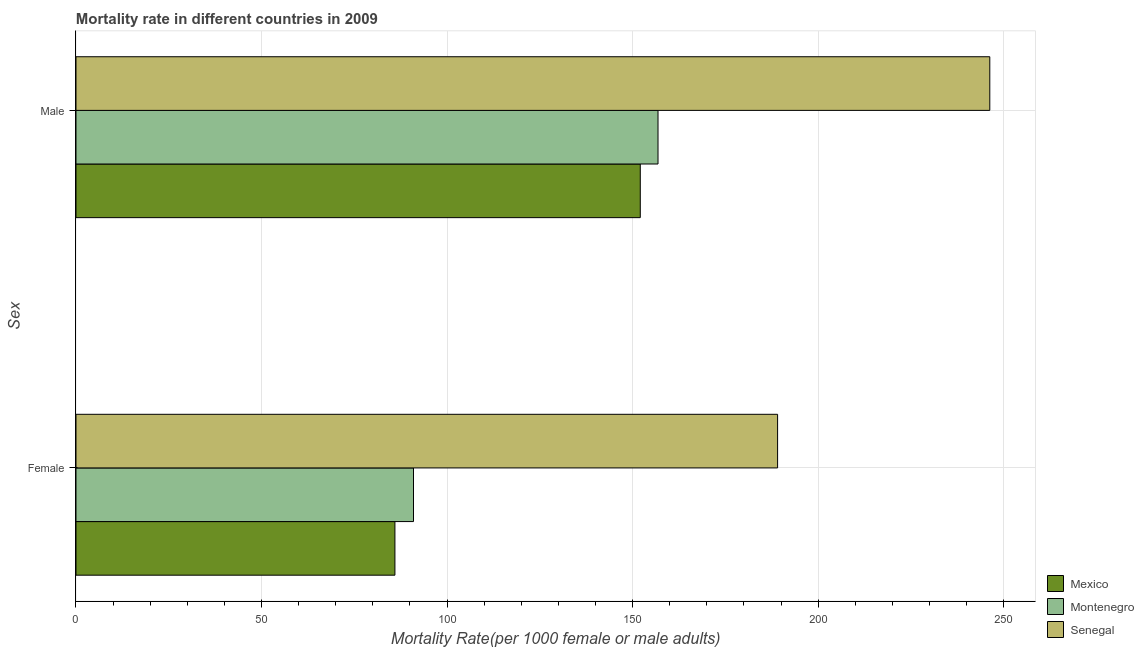How many groups of bars are there?
Offer a very short reply. 2. How many bars are there on the 2nd tick from the top?
Give a very brief answer. 3. What is the female mortality rate in Senegal?
Ensure brevity in your answer.  189.07. Across all countries, what is the maximum male mortality rate?
Your answer should be compact. 246.25. Across all countries, what is the minimum female mortality rate?
Ensure brevity in your answer.  85.95. In which country was the female mortality rate maximum?
Offer a terse response. Senegal. In which country was the female mortality rate minimum?
Provide a succinct answer. Mexico. What is the total female mortality rate in the graph?
Provide a short and direct response. 365.96. What is the difference between the male mortality rate in Senegal and that in Montenegro?
Provide a succinct answer. 89.41. What is the difference between the female mortality rate in Mexico and the male mortality rate in Montenegro?
Keep it short and to the point. -70.9. What is the average male mortality rate per country?
Your answer should be very brief. 185.05. What is the difference between the male mortality rate and female mortality rate in Mexico?
Provide a short and direct response. 66.12. In how many countries, is the female mortality rate greater than 210 ?
Offer a very short reply. 0. What is the ratio of the male mortality rate in Mexico to that in Senegal?
Ensure brevity in your answer.  0.62. Is the female mortality rate in Mexico less than that in Senegal?
Provide a succinct answer. Yes. In how many countries, is the female mortality rate greater than the average female mortality rate taken over all countries?
Offer a very short reply. 1. What does the 1st bar from the top in Male represents?
Your response must be concise. Senegal. What does the 2nd bar from the bottom in Male represents?
Give a very brief answer. Montenegro. How many bars are there?
Your response must be concise. 6. Are the values on the major ticks of X-axis written in scientific E-notation?
Your answer should be compact. No. Does the graph contain grids?
Offer a very short reply. Yes. Where does the legend appear in the graph?
Offer a terse response. Bottom right. How are the legend labels stacked?
Give a very brief answer. Vertical. What is the title of the graph?
Provide a short and direct response. Mortality rate in different countries in 2009. What is the label or title of the X-axis?
Keep it short and to the point. Mortality Rate(per 1000 female or male adults). What is the label or title of the Y-axis?
Give a very brief answer. Sex. What is the Mortality Rate(per 1000 female or male adults) in Mexico in Female?
Keep it short and to the point. 85.95. What is the Mortality Rate(per 1000 female or male adults) in Montenegro in Female?
Give a very brief answer. 90.95. What is the Mortality Rate(per 1000 female or male adults) of Senegal in Female?
Offer a terse response. 189.07. What is the Mortality Rate(per 1000 female or male adults) in Mexico in Male?
Provide a short and direct response. 152.06. What is the Mortality Rate(per 1000 female or male adults) of Montenegro in Male?
Make the answer very short. 156.84. What is the Mortality Rate(per 1000 female or male adults) of Senegal in Male?
Ensure brevity in your answer.  246.25. Across all Sex, what is the maximum Mortality Rate(per 1000 female or male adults) of Mexico?
Give a very brief answer. 152.06. Across all Sex, what is the maximum Mortality Rate(per 1000 female or male adults) of Montenegro?
Your answer should be compact. 156.84. Across all Sex, what is the maximum Mortality Rate(per 1000 female or male adults) of Senegal?
Offer a terse response. 246.25. Across all Sex, what is the minimum Mortality Rate(per 1000 female or male adults) of Mexico?
Keep it short and to the point. 85.95. Across all Sex, what is the minimum Mortality Rate(per 1000 female or male adults) of Montenegro?
Keep it short and to the point. 90.95. Across all Sex, what is the minimum Mortality Rate(per 1000 female or male adults) in Senegal?
Make the answer very short. 189.07. What is the total Mortality Rate(per 1000 female or male adults) in Mexico in the graph?
Ensure brevity in your answer.  238.01. What is the total Mortality Rate(per 1000 female or male adults) in Montenegro in the graph?
Provide a short and direct response. 247.79. What is the total Mortality Rate(per 1000 female or male adults) of Senegal in the graph?
Provide a short and direct response. 435.32. What is the difference between the Mortality Rate(per 1000 female or male adults) of Mexico in Female and that in Male?
Your answer should be compact. -66.12. What is the difference between the Mortality Rate(per 1000 female or male adults) in Montenegro in Female and that in Male?
Offer a terse response. -65.89. What is the difference between the Mortality Rate(per 1000 female or male adults) in Senegal in Female and that in Male?
Your answer should be compact. -57.19. What is the difference between the Mortality Rate(per 1000 female or male adults) in Mexico in Female and the Mortality Rate(per 1000 female or male adults) in Montenegro in Male?
Offer a very short reply. -70.9. What is the difference between the Mortality Rate(per 1000 female or male adults) in Mexico in Female and the Mortality Rate(per 1000 female or male adults) in Senegal in Male?
Your answer should be compact. -160.31. What is the difference between the Mortality Rate(per 1000 female or male adults) in Montenegro in Female and the Mortality Rate(per 1000 female or male adults) in Senegal in Male?
Provide a short and direct response. -155.3. What is the average Mortality Rate(per 1000 female or male adults) in Mexico per Sex?
Offer a terse response. 119. What is the average Mortality Rate(per 1000 female or male adults) of Montenegro per Sex?
Ensure brevity in your answer.  123.9. What is the average Mortality Rate(per 1000 female or male adults) of Senegal per Sex?
Keep it short and to the point. 217.66. What is the difference between the Mortality Rate(per 1000 female or male adults) in Mexico and Mortality Rate(per 1000 female or male adults) in Montenegro in Female?
Offer a terse response. -5. What is the difference between the Mortality Rate(per 1000 female or male adults) of Mexico and Mortality Rate(per 1000 female or male adults) of Senegal in Female?
Ensure brevity in your answer.  -103.12. What is the difference between the Mortality Rate(per 1000 female or male adults) of Montenegro and Mortality Rate(per 1000 female or male adults) of Senegal in Female?
Your response must be concise. -98.12. What is the difference between the Mortality Rate(per 1000 female or male adults) of Mexico and Mortality Rate(per 1000 female or male adults) of Montenegro in Male?
Keep it short and to the point. -4.78. What is the difference between the Mortality Rate(per 1000 female or male adults) in Mexico and Mortality Rate(per 1000 female or male adults) in Senegal in Male?
Your answer should be compact. -94.19. What is the difference between the Mortality Rate(per 1000 female or male adults) in Montenegro and Mortality Rate(per 1000 female or male adults) in Senegal in Male?
Your response must be concise. -89.41. What is the ratio of the Mortality Rate(per 1000 female or male adults) in Mexico in Female to that in Male?
Your answer should be very brief. 0.57. What is the ratio of the Mortality Rate(per 1000 female or male adults) of Montenegro in Female to that in Male?
Keep it short and to the point. 0.58. What is the ratio of the Mortality Rate(per 1000 female or male adults) of Senegal in Female to that in Male?
Your response must be concise. 0.77. What is the difference between the highest and the second highest Mortality Rate(per 1000 female or male adults) in Mexico?
Make the answer very short. 66.12. What is the difference between the highest and the second highest Mortality Rate(per 1000 female or male adults) in Montenegro?
Your response must be concise. 65.89. What is the difference between the highest and the second highest Mortality Rate(per 1000 female or male adults) in Senegal?
Ensure brevity in your answer.  57.19. What is the difference between the highest and the lowest Mortality Rate(per 1000 female or male adults) in Mexico?
Provide a succinct answer. 66.12. What is the difference between the highest and the lowest Mortality Rate(per 1000 female or male adults) in Montenegro?
Provide a short and direct response. 65.89. What is the difference between the highest and the lowest Mortality Rate(per 1000 female or male adults) of Senegal?
Provide a succinct answer. 57.19. 